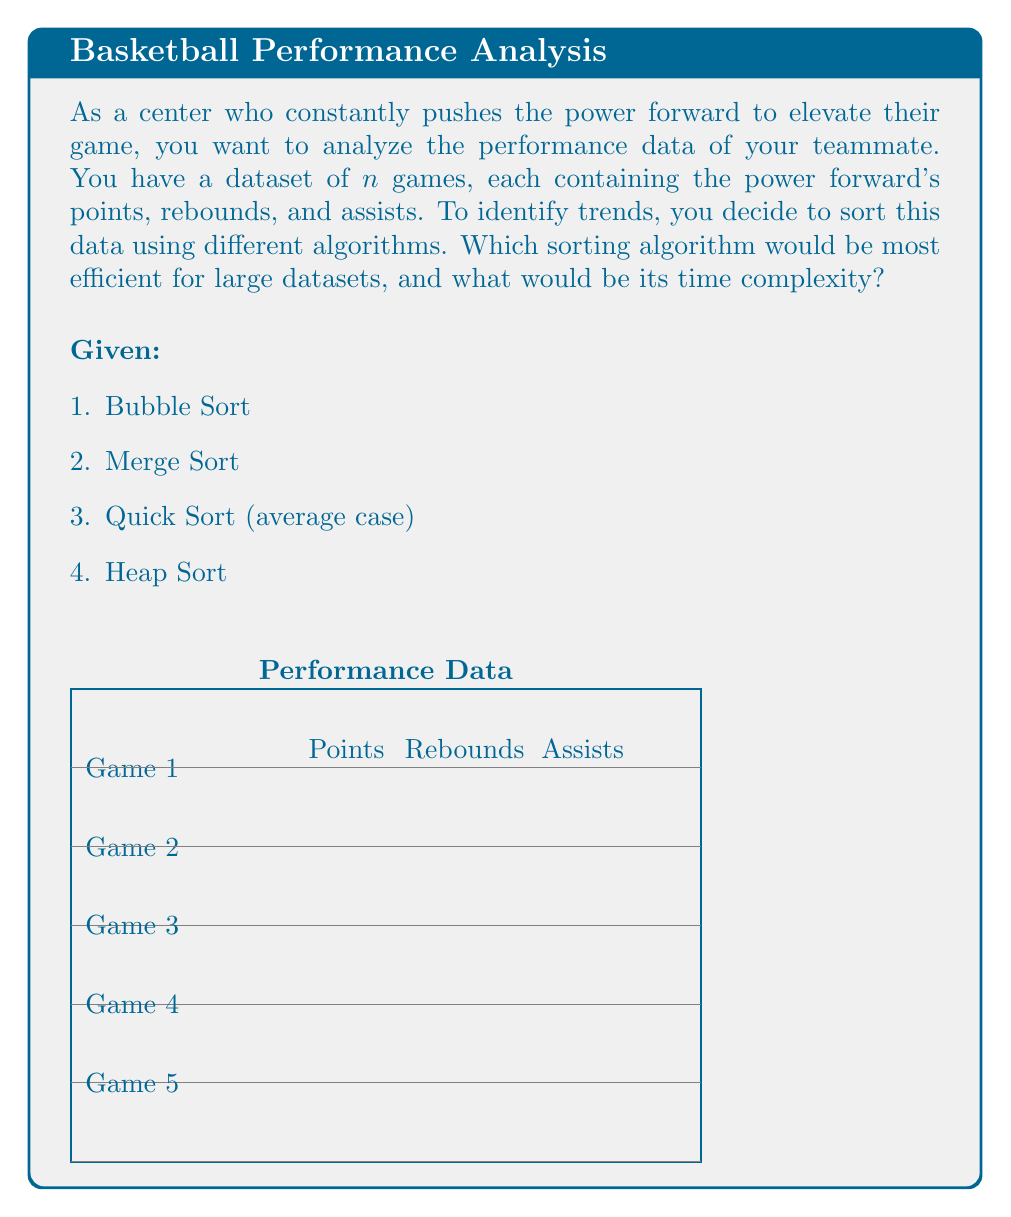Can you answer this question? To determine the most efficient sorting algorithm for large datasets, we need to analyze the time complexity of each algorithm:

1. Bubble Sort:
   - Time complexity: $O(n^2)$
   - Not efficient for large datasets

2. Merge Sort:
   - Time complexity: $O(n \log n)$
   - Efficient for large datasets
   - Stable sort

3. Quick Sort (average case):
   - Time complexity: $O(n \log n)$
   - Efficient for large datasets
   - Generally faster than Merge Sort in practice due to better cache performance

4. Heap Sort:
   - Time complexity: $O(n \log n)$
   - Efficient for large datasets
   - In-place sorting algorithm

Among these, Merge Sort, Quick Sort, and Heap Sort all have a time complexity of $O(n \log n)$, which is more efficient than Bubble Sort's $O(n^2)$ for large datasets.

However, Quick Sort is generally considered the most efficient in practice due to its:
1. Good cache performance
2. In-place sorting (unlike Merge Sort)
3. Average-case time complexity of $O(n \log n)$

The time complexity of Quick Sort can be derived as follows:

1. In each partition step, we divide the array into two parts.
2. On average, these partitions are balanced, resulting in $\log n$ levels of recursion.
3. At each level, we perform $n$ comparisons.

Therefore, the total time complexity is:

$$ T(n) = n + n + n + ... (\log n \text{ times}) = n \log n $$

Hence, Quick Sort with an average-case time complexity of $O(n \log n)$ would be the most efficient for sorting large datasets of player performance data.
Answer: Quick Sort, $O(n \log n)$ 